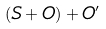Convert formula to latex. <formula><loc_0><loc_0><loc_500><loc_500>( S + O ) + O ^ { \prime }</formula> 